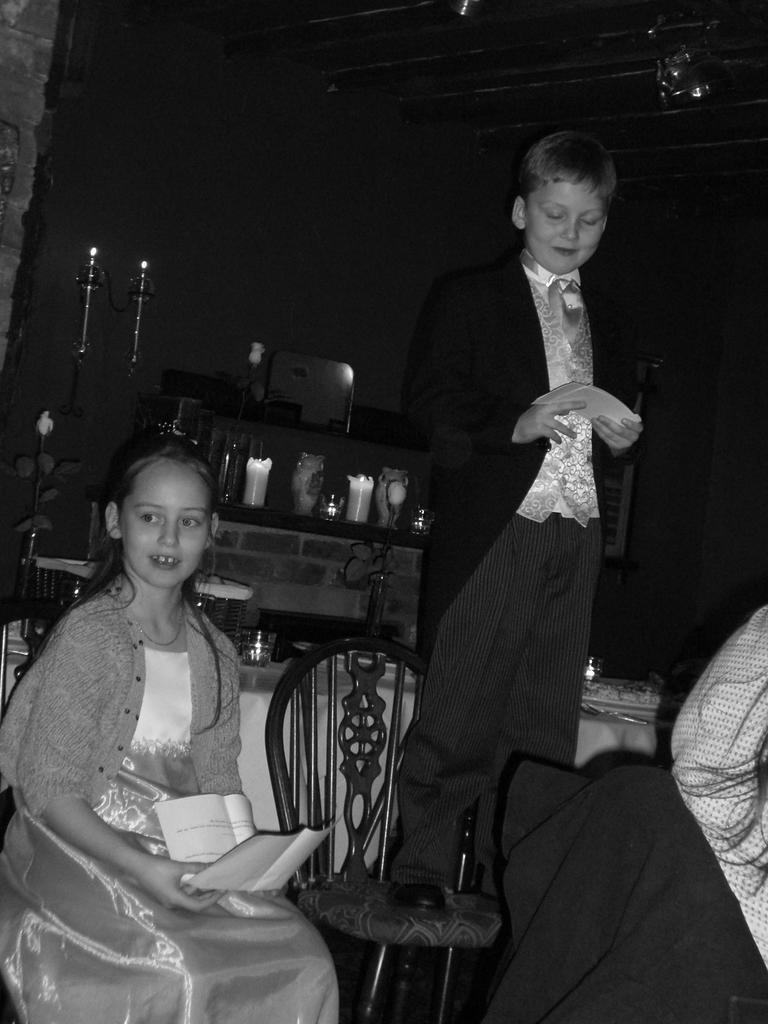Please provide a concise description of this image. This is a black and white image, in this image in the center there is one girl who is sitting and she is holding some papers. Beside her there is one boy who is standing on a chair, and on the right side there is another girl and in the background there are some candles, table, chairs. On the table there are some bowls, and in the background there are some objects and at the top there is ceiling. 